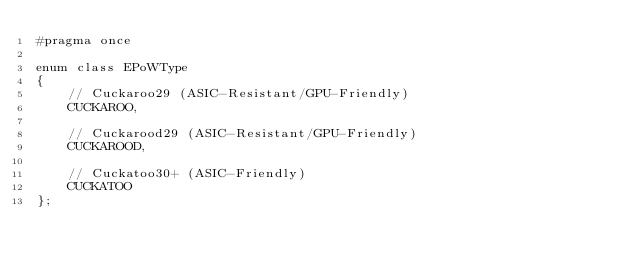Convert code to text. <code><loc_0><loc_0><loc_500><loc_500><_C_>#pragma once

enum class EPoWType
{
	// Cuckaroo29 (ASIC-Resistant/GPU-Friendly)
	CUCKAROO,

	// Cuckarood29 (ASIC-Resistant/GPU-Friendly)
	CUCKAROOD,

	// Cuckatoo30+ (ASIC-Friendly)
	CUCKATOO
};</code> 